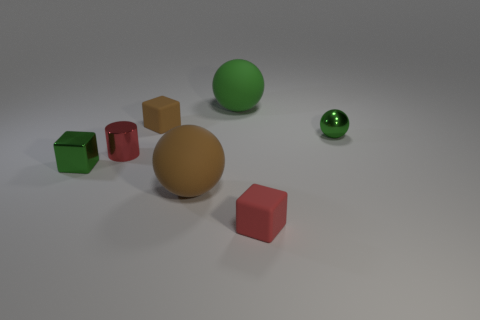What number of other objects are there of the same color as the shiny cube? 2 